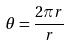<formula> <loc_0><loc_0><loc_500><loc_500>\theta = \frac { 2 \pi r } { r }</formula> 